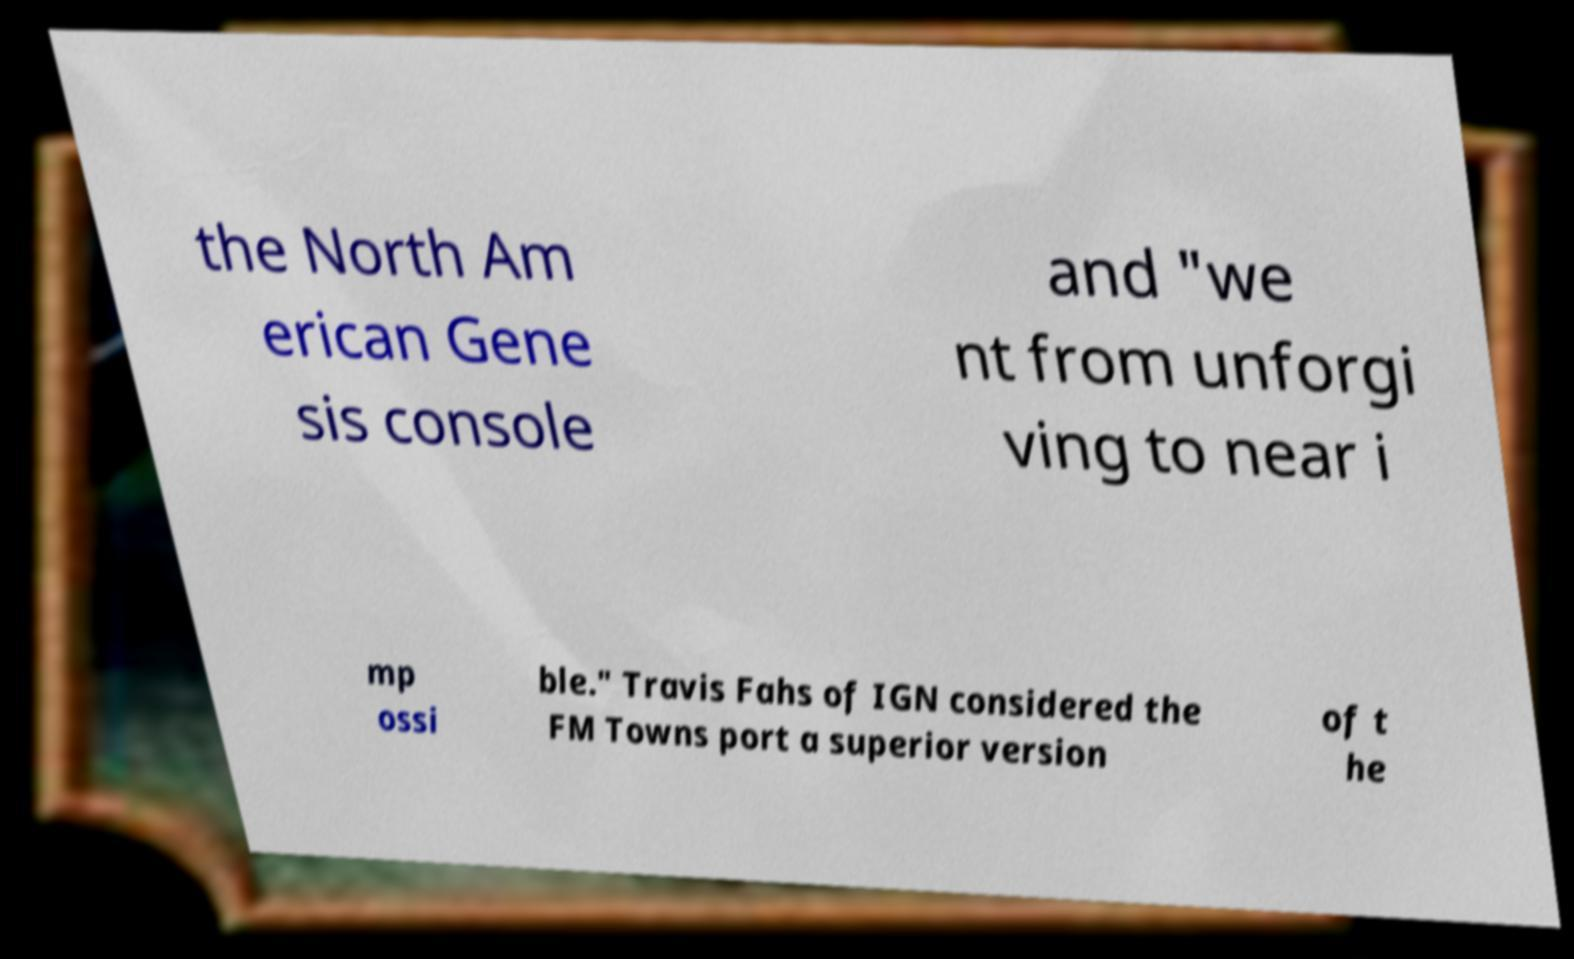Could you assist in decoding the text presented in this image and type it out clearly? the North Am erican Gene sis console and "we nt from unforgi ving to near i mp ossi ble." Travis Fahs of IGN considered the FM Towns port a superior version of t he 